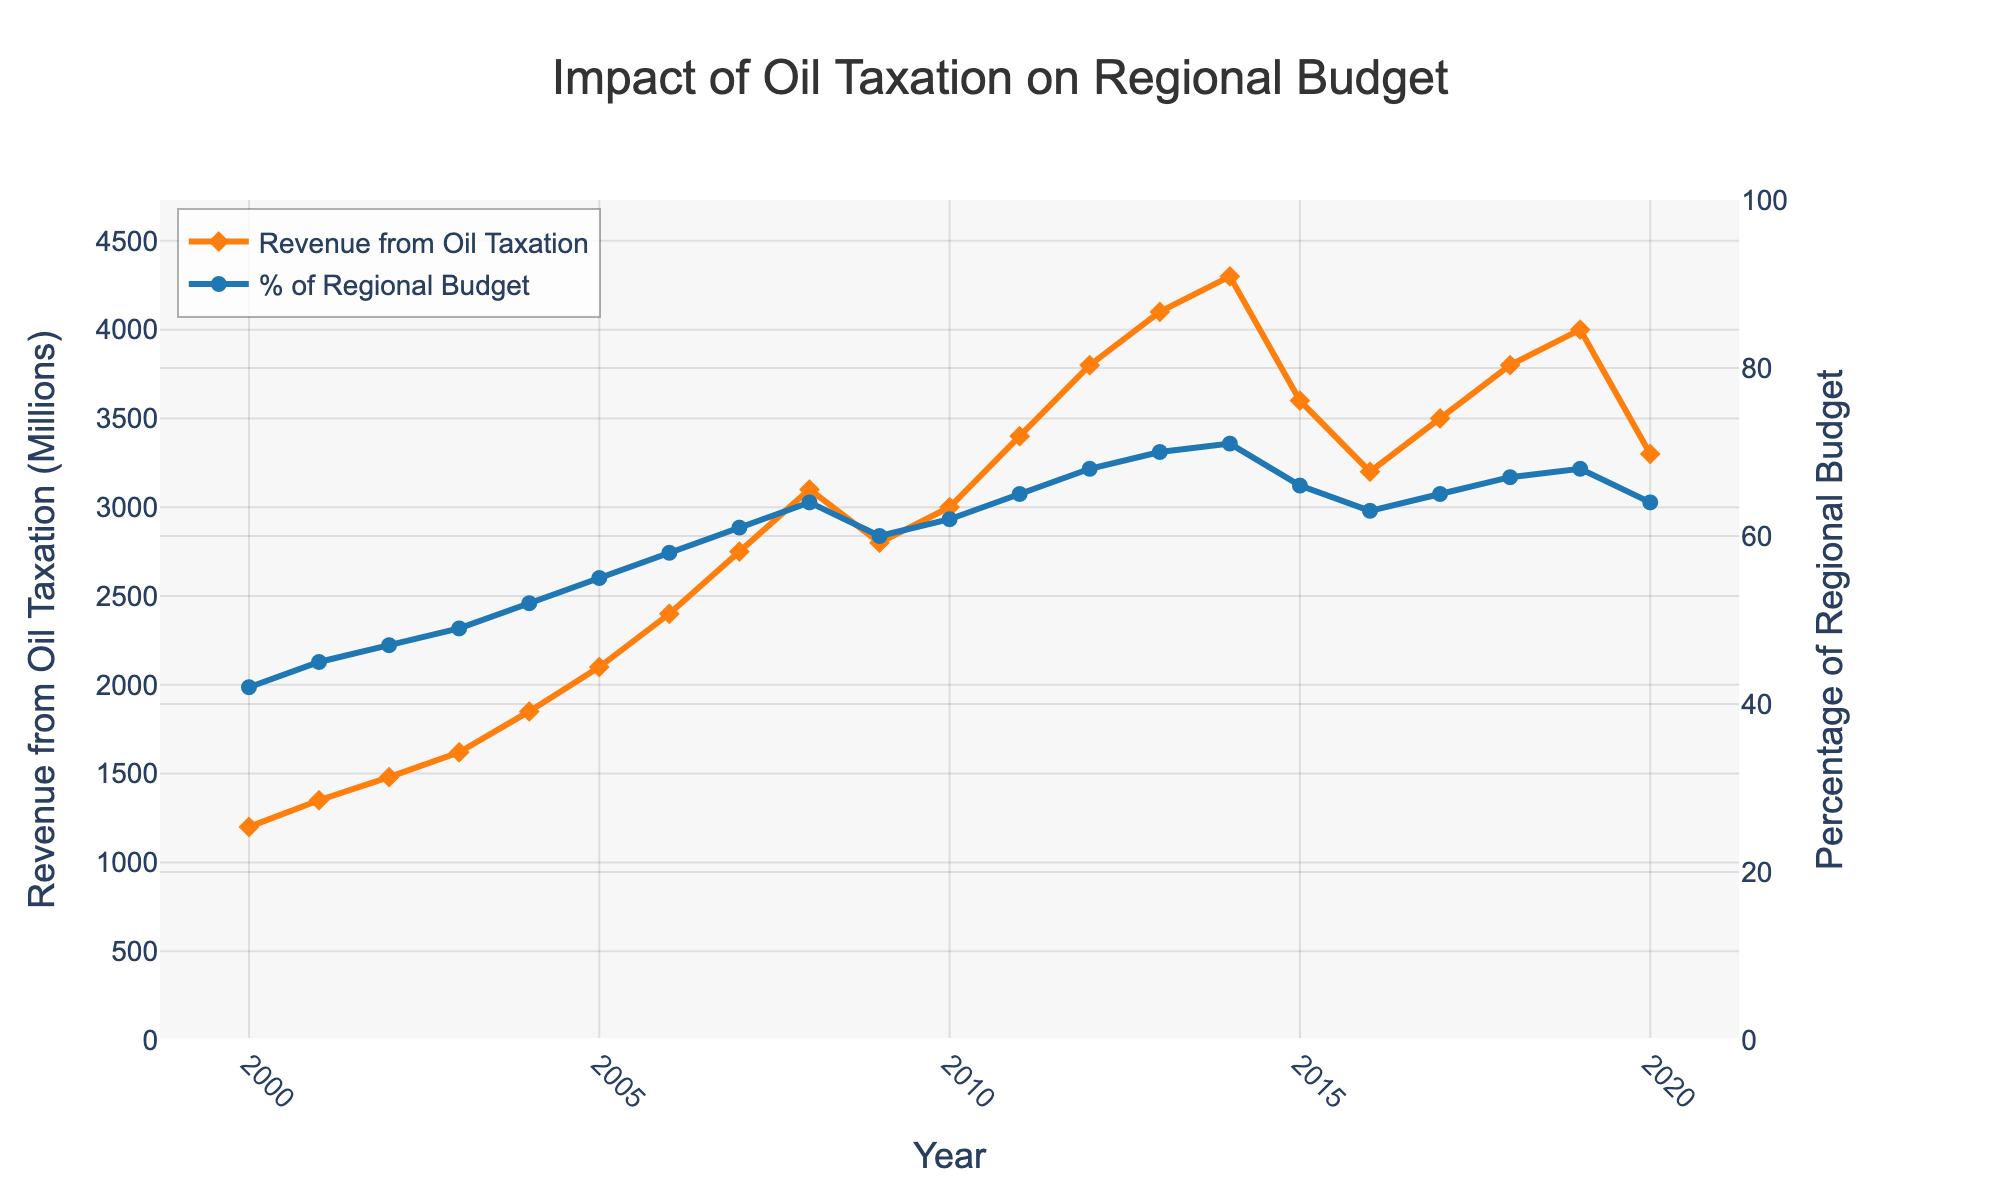What's the peak revenue from oil taxation? Observing the figure, we see that the highest point of the orange line, representing revenue from oil taxation, is in 2014 at $4300 million.
Answer: $4300 million In which year did the percentage of the regional budget from oil taxation first exceed 50%? By analyzing the blue line, we see that the percentage first exceeds 50% in 2004, where it reaches 52%.
Answer: 2004 What's the average revenue from oil taxation from 2000 to 2010? Summing the revenue figures from 2000 to 2010 and dividing by the number of years (11): (1200 + 1350 + 1480 + 1620 + 1850 + 2100 + 2400 + 2750 + 3100 + 2800 + 3000) / 11 = 21,650 / 11 = $1968 million
Answer: $1968 million How did the revenue from oil taxation change between 2008 and 2009? Comparing the values at the respective points, revenue drops from $3100 million in 2008 to $2800 million in 2009, indicating a decrease of $300 million.
Answer: Decrease by $300 million Which year saw the biggest increase in the percentage of the regional budget from oil taxation? Observing the year-on-year changes in the blue line, the largest increase is from 2006 to 2007, where the percentage jumps from 58% to 61%, an increase of 3 percentage points.
Answer: 2007 Was the percentage of the regional budget from oil taxation higher in 2015 or 2020? The blue line shows that in 2015 the percentage was 66%, while in 2020 it was 64%.
Answer: 2015 What was the approximate increase in the revenue from oil taxation between 2005 and 2007? The revenue increases from $2100 million in 2005 to $2750 million in 2007. The difference is $2750 million - $2100 million = $650 million.
Answer: $650 million What is the general trend observable in both the revenue from oil taxation and its percentage of the regional budget from 2000 to 2020? Both the orange and blue lines generally trend upwards over the years, though there are a few fluctuations. This indicates an overall increase in both revenue from oil taxation and its contribution to the regional budget.
Answer: Upward trend with fluctuations 